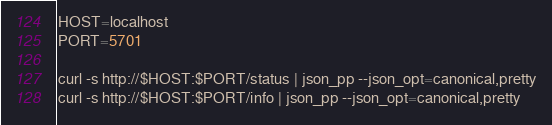Convert code to text. <code><loc_0><loc_0><loc_500><loc_500><_Bash_>HOST=localhost
PORT=5701

curl -s http://$HOST:$PORT/status | json_pp --json_opt=canonical,pretty
curl -s http://$HOST:$PORT/info | json_pp --json_opt=canonical,pretty
</code> 